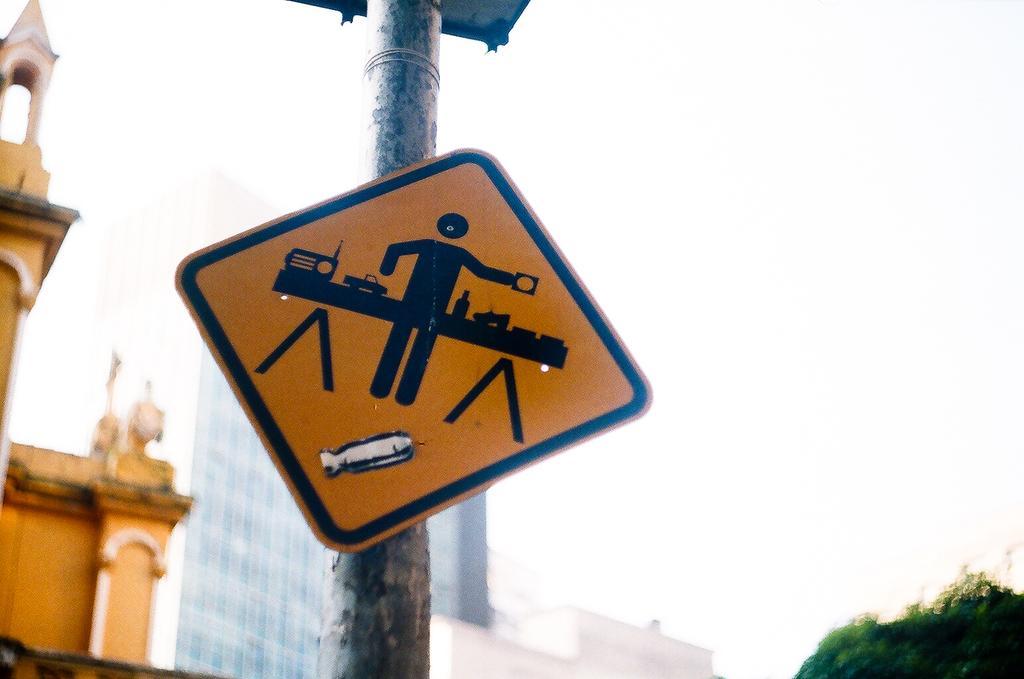Could you give a brief overview of what you see in this image? This picture described about yellow caution board placed on the pole. Behind we can see big glass building. 